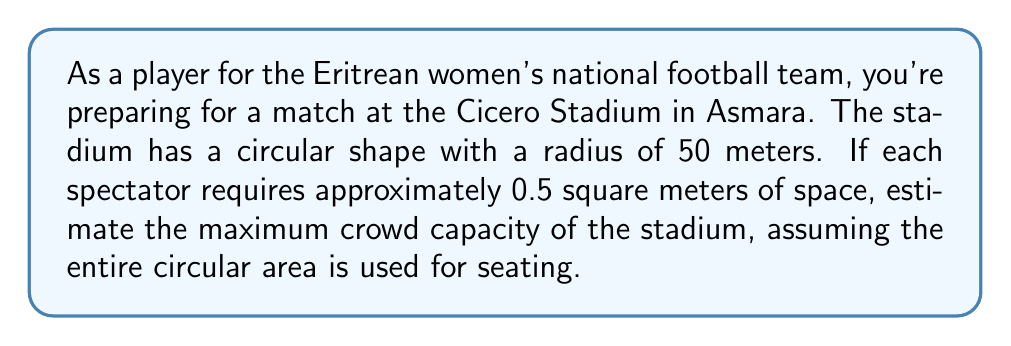Show me your answer to this math problem. To estimate the crowd capacity of the circular Cicero Stadium, we'll follow these steps:

1) First, calculate the total area of the stadium using the formula for the area of a circle:
   
   $A = \pi r^2$

   Where $r$ is the radius of the circle.

2) Substitute the given radius of 50 meters:
   
   $A = \pi (50 \text{ m})^2 = 2500\pi \text{ m}^2$

3) Calculate the exact area:
   
   $A = 7853.98 \text{ m}^2$ (rounded to 2 decimal places)

4) Now, determine how many spectators can fit in this area. We're given that each spectator requires 0.5 square meters of space. To find the number of spectators, divide the total area by the space required per spectator:

   $\text{Number of spectators} = \frac{\text{Total area}}{\text{Area per spectator}}$

   $\text{Number of spectators} = \frac{7853.98 \text{ m}^2}{0.5 \text{ m}^2/\text{person}}$

5) Calculate the result:
   
   $\text{Number of spectators} = 15707.96$

6) Since we can't have a fractional person, round down to the nearest whole number:

   $\text{Estimated crowd capacity} = 15707 \text{ people}$

This estimation assumes the entire circular area is used for seating, which may not be realistic in practice due to the need for walkways, pitch area, and other facilities. However, it provides a theoretical maximum capacity based on the given information.
Answer: 15707 people 